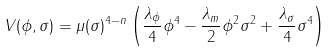Convert formula to latex. <formula><loc_0><loc_0><loc_500><loc_500>V ( \phi , \sigma ) = \mu ( \sigma ) ^ { 4 - n } \left ( \frac { \lambda _ { \phi } } 4 \phi ^ { 4 } - \frac { \lambda _ { m } } 2 \phi ^ { 2 } \sigma ^ { 2 } + \frac { \lambda _ { \sigma } } 4 \sigma ^ { 4 } \right )</formula> 